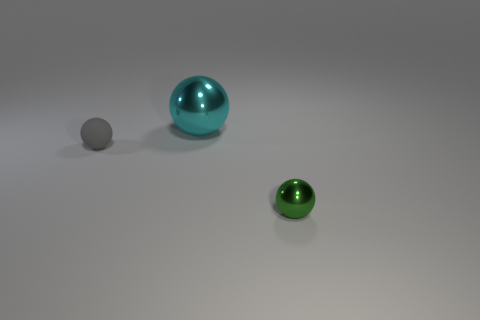What material is the tiny thing that is on the left side of the tiny green object?
Your response must be concise. Rubber. There is a big cyan metallic thing left of the metallic thing in front of the sphere to the left of the cyan object; what is its shape?
Give a very brief answer. Sphere. Are there fewer big spheres that are behind the tiny matte thing than tiny gray matte objects behind the cyan metal ball?
Provide a short and direct response. No. Are there any other things that are the same shape as the cyan object?
Make the answer very short. Yes. There is a tiny matte object that is the same shape as the big metal thing; what is its color?
Provide a succinct answer. Gray. There is a cyan metal object; does it have the same shape as the thing that is to the left of the cyan metallic ball?
Keep it short and to the point. Yes. What number of things are either metallic things behind the small green sphere or balls behind the gray rubber object?
Your response must be concise. 1. What is the material of the large ball?
Your answer should be very brief. Metal. How many other things are the same size as the cyan metallic sphere?
Keep it short and to the point. 0. What is the size of the metallic ball that is in front of the large shiny ball?
Keep it short and to the point. Small. 